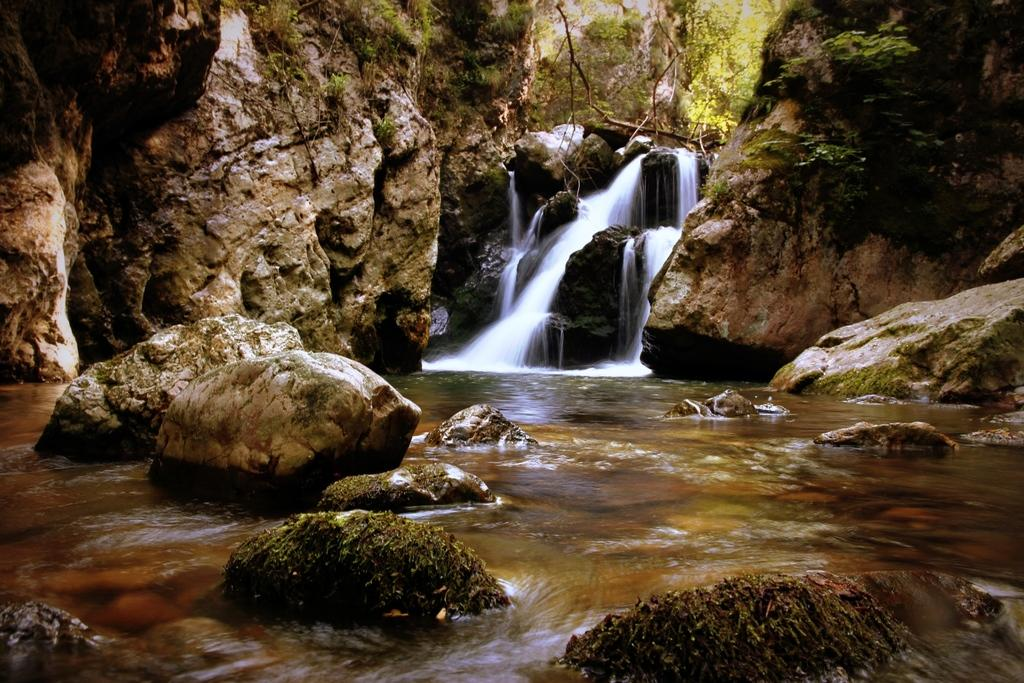What is the primary element in the image? There is water in the image. What can be seen within the water? There are rocks in the water. What is visible in the background of the image? There is a waterfall and huge rocks in the background of the image. What type of vegetation is present in the background of the image? There are trees in the background of the image. What type of cord is being used to control the waterfall in the image? There is no cord visible in the image, and the waterfall is a natural feature, not controlled by any device. 